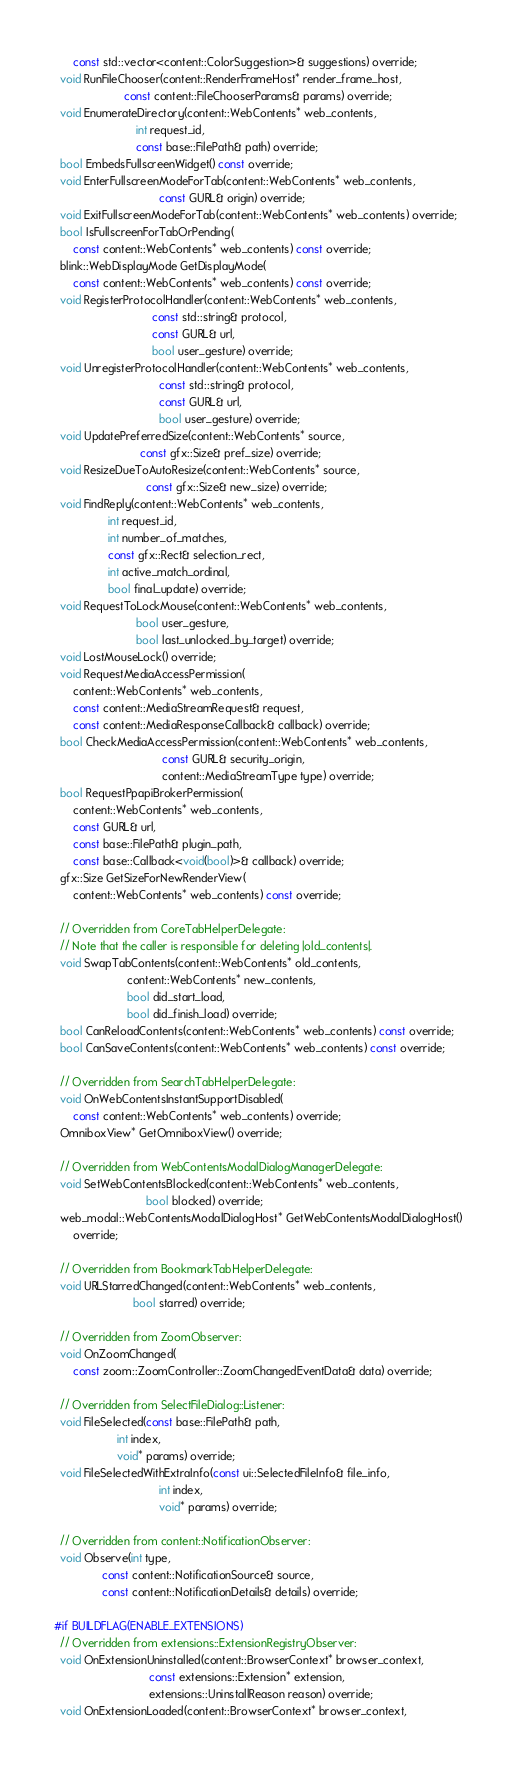Convert code to text. <code><loc_0><loc_0><loc_500><loc_500><_C_>      const std::vector<content::ColorSuggestion>& suggestions) override;
  void RunFileChooser(content::RenderFrameHost* render_frame_host,
                      const content::FileChooserParams& params) override;
  void EnumerateDirectory(content::WebContents* web_contents,
                          int request_id,
                          const base::FilePath& path) override;
  bool EmbedsFullscreenWidget() const override;
  void EnterFullscreenModeForTab(content::WebContents* web_contents,
                                 const GURL& origin) override;
  void ExitFullscreenModeForTab(content::WebContents* web_contents) override;
  bool IsFullscreenForTabOrPending(
      const content::WebContents* web_contents) const override;
  blink::WebDisplayMode GetDisplayMode(
      const content::WebContents* web_contents) const override;
  void RegisterProtocolHandler(content::WebContents* web_contents,
                               const std::string& protocol,
                               const GURL& url,
                               bool user_gesture) override;
  void UnregisterProtocolHandler(content::WebContents* web_contents,
                                 const std::string& protocol,
                                 const GURL& url,
                                 bool user_gesture) override;
  void UpdatePreferredSize(content::WebContents* source,
                           const gfx::Size& pref_size) override;
  void ResizeDueToAutoResize(content::WebContents* source,
                             const gfx::Size& new_size) override;
  void FindReply(content::WebContents* web_contents,
                 int request_id,
                 int number_of_matches,
                 const gfx::Rect& selection_rect,
                 int active_match_ordinal,
                 bool final_update) override;
  void RequestToLockMouse(content::WebContents* web_contents,
                          bool user_gesture,
                          bool last_unlocked_by_target) override;
  void LostMouseLock() override;
  void RequestMediaAccessPermission(
      content::WebContents* web_contents,
      const content::MediaStreamRequest& request,
      const content::MediaResponseCallback& callback) override;
  bool CheckMediaAccessPermission(content::WebContents* web_contents,
                                  const GURL& security_origin,
                                  content::MediaStreamType type) override;
  bool RequestPpapiBrokerPermission(
      content::WebContents* web_contents,
      const GURL& url,
      const base::FilePath& plugin_path,
      const base::Callback<void(bool)>& callback) override;
  gfx::Size GetSizeForNewRenderView(
      content::WebContents* web_contents) const override;

  // Overridden from CoreTabHelperDelegate:
  // Note that the caller is responsible for deleting |old_contents|.
  void SwapTabContents(content::WebContents* old_contents,
                       content::WebContents* new_contents,
                       bool did_start_load,
                       bool did_finish_load) override;
  bool CanReloadContents(content::WebContents* web_contents) const override;
  bool CanSaveContents(content::WebContents* web_contents) const override;

  // Overridden from SearchTabHelperDelegate:
  void OnWebContentsInstantSupportDisabled(
      const content::WebContents* web_contents) override;
  OmniboxView* GetOmniboxView() override;

  // Overridden from WebContentsModalDialogManagerDelegate:
  void SetWebContentsBlocked(content::WebContents* web_contents,
                             bool blocked) override;
  web_modal::WebContentsModalDialogHost* GetWebContentsModalDialogHost()
      override;

  // Overridden from BookmarkTabHelperDelegate:
  void URLStarredChanged(content::WebContents* web_contents,
                         bool starred) override;

  // Overridden from ZoomObserver:
  void OnZoomChanged(
      const zoom::ZoomController::ZoomChangedEventData& data) override;

  // Overridden from SelectFileDialog::Listener:
  void FileSelected(const base::FilePath& path,
                    int index,
                    void* params) override;
  void FileSelectedWithExtraInfo(const ui::SelectedFileInfo& file_info,
                                 int index,
                                 void* params) override;

  // Overridden from content::NotificationObserver:
  void Observe(int type,
               const content::NotificationSource& source,
               const content::NotificationDetails& details) override;

#if BUILDFLAG(ENABLE_EXTENSIONS)
  // Overridden from extensions::ExtensionRegistryObserver:
  void OnExtensionUninstalled(content::BrowserContext* browser_context,
                              const extensions::Extension* extension,
                              extensions::UninstallReason reason) override;
  void OnExtensionLoaded(content::BrowserContext* browser_context,</code> 